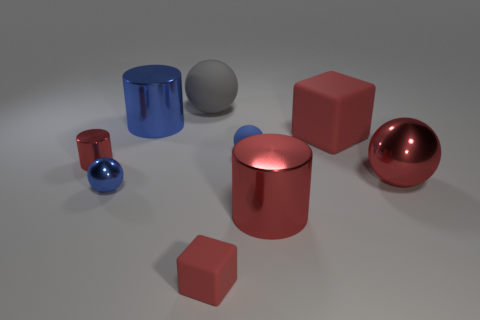Subtract all big red metal cylinders. How many cylinders are left? 2 Subtract all blue cylinders. How many cylinders are left? 2 Subtract all gray balls. How many red cylinders are left? 2 Subtract all balls. How many objects are left? 5 Subtract all cyan blocks. Subtract all gray spheres. How many blocks are left? 2 Subtract all tiny cylinders. Subtract all big gray objects. How many objects are left? 7 Add 1 small matte spheres. How many small matte spheres are left? 2 Add 5 tiny cyan matte cylinders. How many tiny cyan matte cylinders exist? 5 Subtract 0 brown cylinders. How many objects are left? 9 